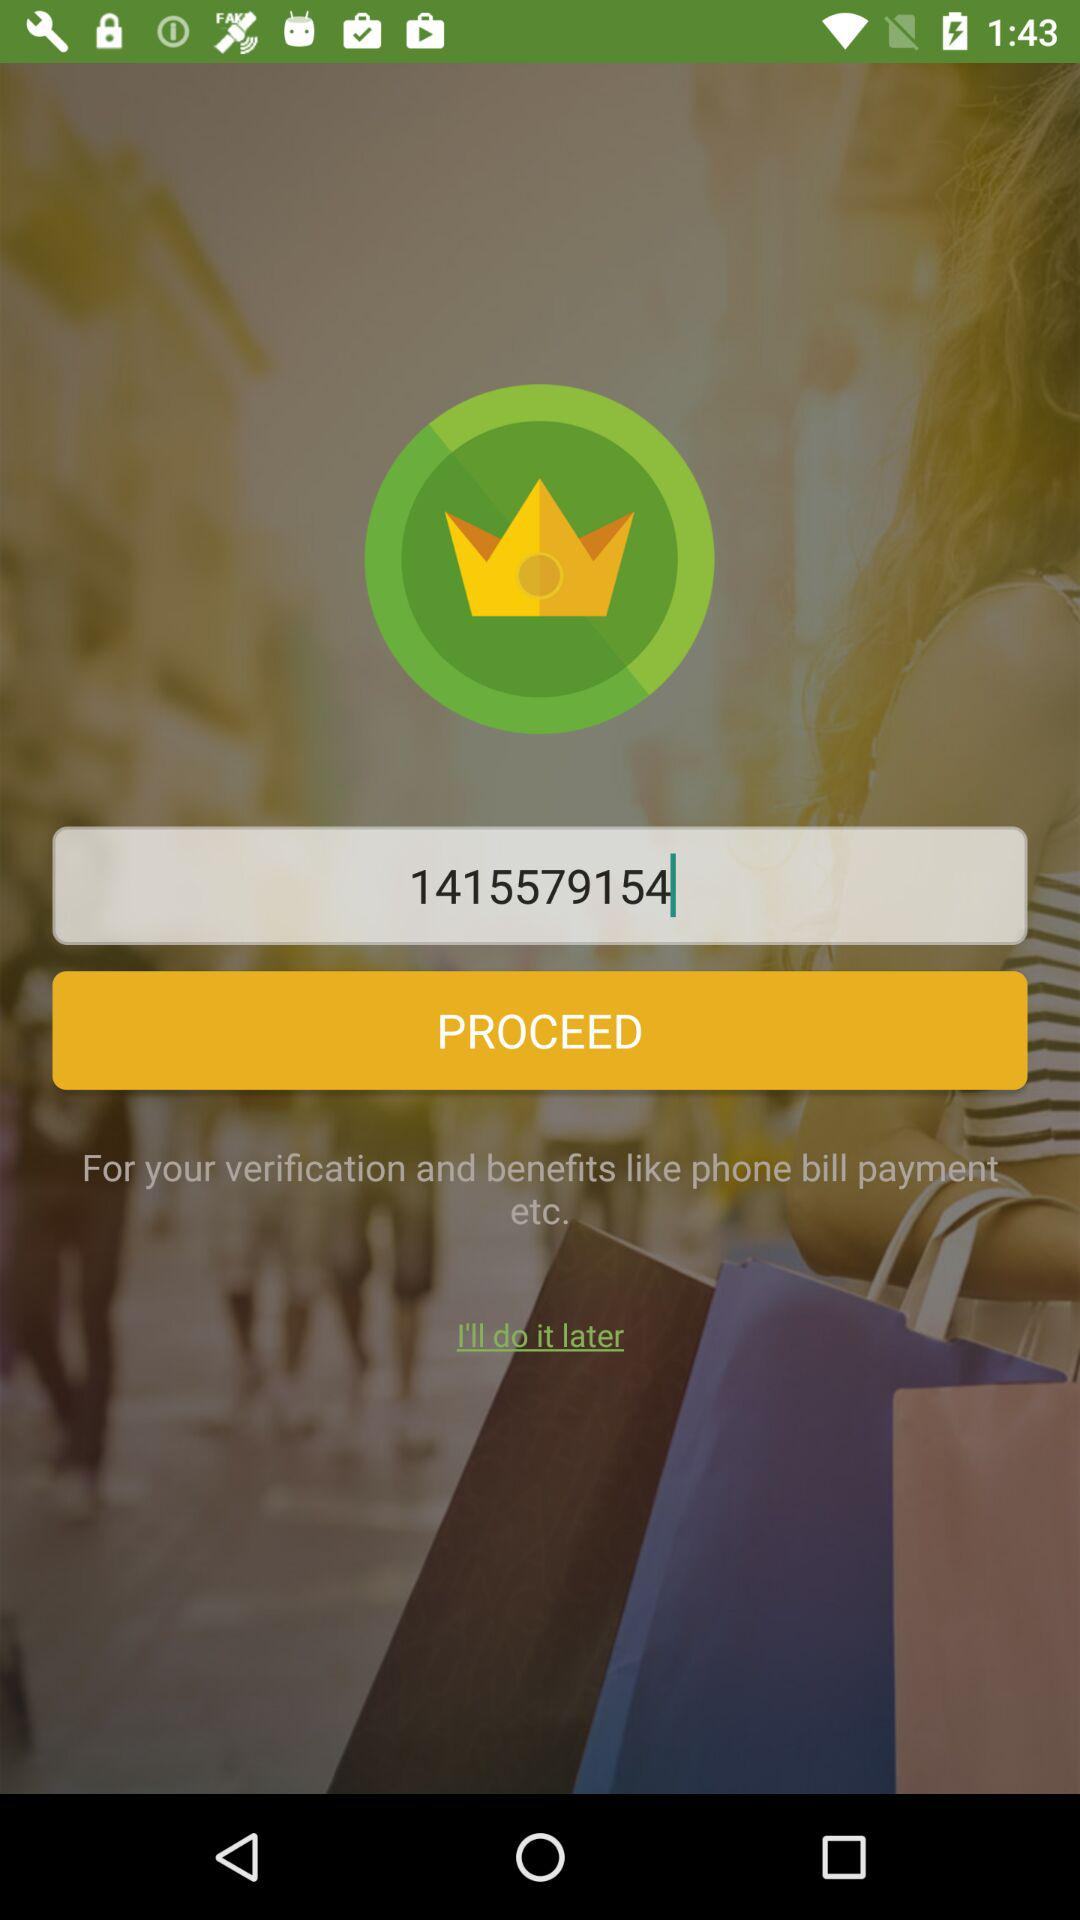How much does the user's phone bill cost?
When the provided information is insufficient, respond with <no answer>. <no answer> 